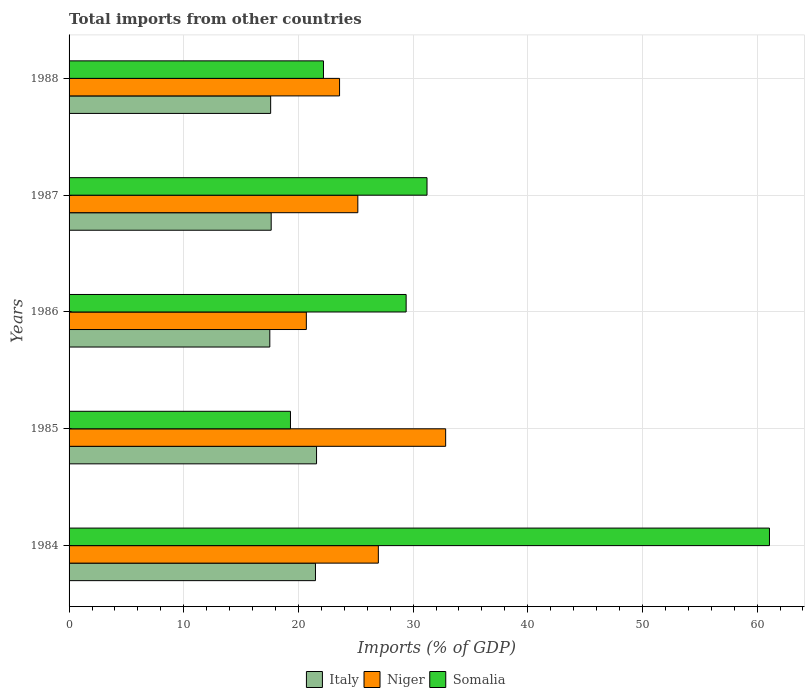How many different coloured bars are there?
Your response must be concise. 3. How many groups of bars are there?
Offer a terse response. 5. How many bars are there on the 2nd tick from the top?
Offer a very short reply. 3. What is the label of the 2nd group of bars from the top?
Provide a succinct answer. 1987. In how many cases, is the number of bars for a given year not equal to the number of legend labels?
Ensure brevity in your answer.  0. What is the total imports in Niger in 1984?
Provide a short and direct response. 26.97. Across all years, what is the maximum total imports in Italy?
Give a very brief answer. 21.58. Across all years, what is the minimum total imports in Niger?
Offer a terse response. 20.69. In which year was the total imports in Somalia maximum?
Your response must be concise. 1984. What is the total total imports in Somalia in the graph?
Provide a short and direct response. 163.18. What is the difference between the total imports in Somalia in 1985 and that in 1986?
Offer a terse response. -10.09. What is the difference between the total imports in Somalia in 1987 and the total imports in Italy in 1986?
Offer a terse response. 13.71. What is the average total imports in Niger per year?
Provide a succinct answer. 25.85. In the year 1984, what is the difference between the total imports in Italy and total imports in Niger?
Provide a short and direct response. -5.48. What is the ratio of the total imports in Somalia in 1984 to that in 1987?
Your response must be concise. 1.96. Is the total imports in Niger in 1985 less than that in 1986?
Provide a short and direct response. No. Is the difference between the total imports in Italy in 1987 and 1988 greater than the difference between the total imports in Niger in 1987 and 1988?
Your response must be concise. No. What is the difference between the highest and the second highest total imports in Somalia?
Provide a short and direct response. 29.86. What is the difference between the highest and the lowest total imports in Italy?
Give a very brief answer. 4.08. Is the sum of the total imports in Niger in 1984 and 1987 greater than the maximum total imports in Somalia across all years?
Make the answer very short. No. What does the 2nd bar from the bottom in 1986 represents?
Your response must be concise. Niger. Is it the case that in every year, the sum of the total imports in Somalia and total imports in Italy is greater than the total imports in Niger?
Your response must be concise. Yes. How many bars are there?
Give a very brief answer. 15. Are all the bars in the graph horizontal?
Give a very brief answer. Yes. How many years are there in the graph?
Provide a succinct answer. 5. Are the values on the major ticks of X-axis written in scientific E-notation?
Your answer should be compact. No. How are the legend labels stacked?
Your answer should be very brief. Horizontal. What is the title of the graph?
Give a very brief answer. Total imports from other countries. Does "Macao" appear as one of the legend labels in the graph?
Give a very brief answer. No. What is the label or title of the X-axis?
Offer a terse response. Imports (% of GDP). What is the label or title of the Y-axis?
Provide a succinct answer. Years. What is the Imports (% of GDP) of Italy in 1984?
Your answer should be very brief. 21.49. What is the Imports (% of GDP) in Niger in 1984?
Your answer should be compact. 26.97. What is the Imports (% of GDP) of Somalia in 1984?
Your answer should be very brief. 61.08. What is the Imports (% of GDP) of Italy in 1985?
Your answer should be compact. 21.58. What is the Imports (% of GDP) of Niger in 1985?
Offer a very short reply. 32.84. What is the Imports (% of GDP) in Somalia in 1985?
Your response must be concise. 19.31. What is the Imports (% of GDP) of Italy in 1986?
Offer a terse response. 17.51. What is the Imports (% of GDP) of Niger in 1986?
Provide a short and direct response. 20.69. What is the Imports (% of GDP) in Somalia in 1986?
Offer a very short reply. 29.39. What is the Imports (% of GDP) of Italy in 1987?
Your answer should be compact. 17.63. What is the Imports (% of GDP) in Niger in 1987?
Ensure brevity in your answer.  25.18. What is the Imports (% of GDP) of Somalia in 1987?
Offer a terse response. 31.21. What is the Imports (% of GDP) in Italy in 1988?
Your answer should be compact. 17.58. What is the Imports (% of GDP) of Niger in 1988?
Ensure brevity in your answer.  23.59. What is the Imports (% of GDP) of Somalia in 1988?
Offer a very short reply. 22.18. Across all years, what is the maximum Imports (% of GDP) in Italy?
Provide a short and direct response. 21.58. Across all years, what is the maximum Imports (% of GDP) of Niger?
Offer a terse response. 32.84. Across all years, what is the maximum Imports (% of GDP) of Somalia?
Keep it short and to the point. 61.08. Across all years, what is the minimum Imports (% of GDP) in Italy?
Your answer should be very brief. 17.51. Across all years, what is the minimum Imports (% of GDP) of Niger?
Keep it short and to the point. 20.69. Across all years, what is the minimum Imports (% of GDP) in Somalia?
Offer a very short reply. 19.31. What is the total Imports (% of GDP) in Italy in the graph?
Keep it short and to the point. 95.78. What is the total Imports (% of GDP) in Niger in the graph?
Keep it short and to the point. 129.27. What is the total Imports (% of GDP) of Somalia in the graph?
Provide a short and direct response. 163.18. What is the difference between the Imports (% of GDP) in Italy in 1984 and that in 1985?
Provide a succinct answer. -0.09. What is the difference between the Imports (% of GDP) of Niger in 1984 and that in 1985?
Your response must be concise. -5.87. What is the difference between the Imports (% of GDP) of Somalia in 1984 and that in 1985?
Your answer should be compact. 41.77. What is the difference between the Imports (% of GDP) in Italy in 1984 and that in 1986?
Make the answer very short. 3.98. What is the difference between the Imports (% of GDP) in Niger in 1984 and that in 1986?
Offer a terse response. 6.28. What is the difference between the Imports (% of GDP) of Somalia in 1984 and that in 1986?
Make the answer very short. 31.68. What is the difference between the Imports (% of GDP) of Italy in 1984 and that in 1987?
Make the answer very short. 3.86. What is the difference between the Imports (% of GDP) in Niger in 1984 and that in 1987?
Offer a very short reply. 1.79. What is the difference between the Imports (% of GDP) of Somalia in 1984 and that in 1987?
Offer a very short reply. 29.86. What is the difference between the Imports (% of GDP) of Italy in 1984 and that in 1988?
Give a very brief answer. 3.91. What is the difference between the Imports (% of GDP) in Niger in 1984 and that in 1988?
Provide a short and direct response. 3.38. What is the difference between the Imports (% of GDP) in Somalia in 1984 and that in 1988?
Your response must be concise. 38.89. What is the difference between the Imports (% of GDP) of Italy in 1985 and that in 1986?
Give a very brief answer. 4.08. What is the difference between the Imports (% of GDP) of Niger in 1985 and that in 1986?
Your answer should be very brief. 12.15. What is the difference between the Imports (% of GDP) in Somalia in 1985 and that in 1986?
Your response must be concise. -10.09. What is the difference between the Imports (% of GDP) of Italy in 1985 and that in 1987?
Offer a terse response. 3.96. What is the difference between the Imports (% of GDP) of Niger in 1985 and that in 1987?
Ensure brevity in your answer.  7.66. What is the difference between the Imports (% of GDP) in Somalia in 1985 and that in 1987?
Ensure brevity in your answer.  -11.91. What is the difference between the Imports (% of GDP) of Italy in 1985 and that in 1988?
Ensure brevity in your answer.  4. What is the difference between the Imports (% of GDP) of Niger in 1985 and that in 1988?
Make the answer very short. 9.25. What is the difference between the Imports (% of GDP) of Somalia in 1985 and that in 1988?
Offer a terse response. -2.88. What is the difference between the Imports (% of GDP) in Italy in 1986 and that in 1987?
Ensure brevity in your answer.  -0.12. What is the difference between the Imports (% of GDP) in Niger in 1986 and that in 1987?
Give a very brief answer. -4.49. What is the difference between the Imports (% of GDP) of Somalia in 1986 and that in 1987?
Offer a very short reply. -1.82. What is the difference between the Imports (% of GDP) in Italy in 1986 and that in 1988?
Provide a short and direct response. -0.07. What is the difference between the Imports (% of GDP) of Niger in 1986 and that in 1988?
Offer a very short reply. -2.9. What is the difference between the Imports (% of GDP) of Somalia in 1986 and that in 1988?
Provide a succinct answer. 7.21. What is the difference between the Imports (% of GDP) of Italy in 1987 and that in 1988?
Your answer should be very brief. 0.05. What is the difference between the Imports (% of GDP) of Niger in 1987 and that in 1988?
Your response must be concise. 1.59. What is the difference between the Imports (% of GDP) of Somalia in 1987 and that in 1988?
Offer a terse response. 9.03. What is the difference between the Imports (% of GDP) of Italy in 1984 and the Imports (% of GDP) of Niger in 1985?
Offer a terse response. -11.35. What is the difference between the Imports (% of GDP) in Italy in 1984 and the Imports (% of GDP) in Somalia in 1985?
Ensure brevity in your answer.  2.18. What is the difference between the Imports (% of GDP) of Niger in 1984 and the Imports (% of GDP) of Somalia in 1985?
Give a very brief answer. 7.66. What is the difference between the Imports (% of GDP) of Italy in 1984 and the Imports (% of GDP) of Niger in 1986?
Keep it short and to the point. 0.8. What is the difference between the Imports (% of GDP) of Italy in 1984 and the Imports (% of GDP) of Somalia in 1986?
Offer a very short reply. -7.91. What is the difference between the Imports (% of GDP) in Niger in 1984 and the Imports (% of GDP) in Somalia in 1986?
Your answer should be very brief. -2.42. What is the difference between the Imports (% of GDP) of Italy in 1984 and the Imports (% of GDP) of Niger in 1987?
Your answer should be very brief. -3.69. What is the difference between the Imports (% of GDP) of Italy in 1984 and the Imports (% of GDP) of Somalia in 1987?
Give a very brief answer. -9.73. What is the difference between the Imports (% of GDP) of Niger in 1984 and the Imports (% of GDP) of Somalia in 1987?
Make the answer very short. -4.24. What is the difference between the Imports (% of GDP) of Italy in 1984 and the Imports (% of GDP) of Niger in 1988?
Your answer should be very brief. -2.1. What is the difference between the Imports (% of GDP) in Italy in 1984 and the Imports (% of GDP) in Somalia in 1988?
Keep it short and to the point. -0.7. What is the difference between the Imports (% of GDP) in Niger in 1984 and the Imports (% of GDP) in Somalia in 1988?
Ensure brevity in your answer.  4.79. What is the difference between the Imports (% of GDP) in Italy in 1985 and the Imports (% of GDP) in Niger in 1986?
Ensure brevity in your answer.  0.89. What is the difference between the Imports (% of GDP) of Italy in 1985 and the Imports (% of GDP) of Somalia in 1986?
Provide a succinct answer. -7.81. What is the difference between the Imports (% of GDP) in Niger in 1985 and the Imports (% of GDP) in Somalia in 1986?
Provide a succinct answer. 3.45. What is the difference between the Imports (% of GDP) of Italy in 1985 and the Imports (% of GDP) of Niger in 1987?
Provide a short and direct response. -3.6. What is the difference between the Imports (% of GDP) of Italy in 1985 and the Imports (% of GDP) of Somalia in 1987?
Provide a short and direct response. -9.63. What is the difference between the Imports (% of GDP) of Niger in 1985 and the Imports (% of GDP) of Somalia in 1987?
Your answer should be very brief. 1.63. What is the difference between the Imports (% of GDP) of Italy in 1985 and the Imports (% of GDP) of Niger in 1988?
Your response must be concise. -2.01. What is the difference between the Imports (% of GDP) in Italy in 1985 and the Imports (% of GDP) in Somalia in 1988?
Keep it short and to the point. -0.6. What is the difference between the Imports (% of GDP) in Niger in 1985 and the Imports (% of GDP) in Somalia in 1988?
Keep it short and to the point. 10.66. What is the difference between the Imports (% of GDP) of Italy in 1986 and the Imports (% of GDP) of Niger in 1987?
Give a very brief answer. -7.68. What is the difference between the Imports (% of GDP) in Italy in 1986 and the Imports (% of GDP) in Somalia in 1987?
Offer a very short reply. -13.71. What is the difference between the Imports (% of GDP) of Niger in 1986 and the Imports (% of GDP) of Somalia in 1987?
Ensure brevity in your answer.  -10.52. What is the difference between the Imports (% of GDP) of Italy in 1986 and the Imports (% of GDP) of Niger in 1988?
Your response must be concise. -6.08. What is the difference between the Imports (% of GDP) in Italy in 1986 and the Imports (% of GDP) in Somalia in 1988?
Your response must be concise. -4.68. What is the difference between the Imports (% of GDP) of Niger in 1986 and the Imports (% of GDP) of Somalia in 1988?
Offer a very short reply. -1.49. What is the difference between the Imports (% of GDP) in Italy in 1987 and the Imports (% of GDP) in Niger in 1988?
Provide a short and direct response. -5.96. What is the difference between the Imports (% of GDP) of Italy in 1987 and the Imports (% of GDP) of Somalia in 1988?
Keep it short and to the point. -4.56. What is the difference between the Imports (% of GDP) in Niger in 1987 and the Imports (% of GDP) in Somalia in 1988?
Your answer should be very brief. 3. What is the average Imports (% of GDP) in Italy per year?
Give a very brief answer. 19.16. What is the average Imports (% of GDP) in Niger per year?
Ensure brevity in your answer.  25.85. What is the average Imports (% of GDP) of Somalia per year?
Give a very brief answer. 32.64. In the year 1984, what is the difference between the Imports (% of GDP) of Italy and Imports (% of GDP) of Niger?
Provide a short and direct response. -5.48. In the year 1984, what is the difference between the Imports (% of GDP) of Italy and Imports (% of GDP) of Somalia?
Your answer should be compact. -39.59. In the year 1984, what is the difference between the Imports (% of GDP) in Niger and Imports (% of GDP) in Somalia?
Ensure brevity in your answer.  -34.11. In the year 1985, what is the difference between the Imports (% of GDP) in Italy and Imports (% of GDP) in Niger?
Your response must be concise. -11.26. In the year 1985, what is the difference between the Imports (% of GDP) of Italy and Imports (% of GDP) of Somalia?
Your response must be concise. 2.27. In the year 1985, what is the difference between the Imports (% of GDP) in Niger and Imports (% of GDP) in Somalia?
Your answer should be compact. 13.53. In the year 1986, what is the difference between the Imports (% of GDP) in Italy and Imports (% of GDP) in Niger?
Ensure brevity in your answer.  -3.19. In the year 1986, what is the difference between the Imports (% of GDP) in Italy and Imports (% of GDP) in Somalia?
Your response must be concise. -11.89. In the year 1986, what is the difference between the Imports (% of GDP) in Niger and Imports (% of GDP) in Somalia?
Offer a terse response. -8.7. In the year 1987, what is the difference between the Imports (% of GDP) of Italy and Imports (% of GDP) of Niger?
Make the answer very short. -7.56. In the year 1987, what is the difference between the Imports (% of GDP) in Italy and Imports (% of GDP) in Somalia?
Provide a succinct answer. -13.59. In the year 1987, what is the difference between the Imports (% of GDP) of Niger and Imports (% of GDP) of Somalia?
Your response must be concise. -6.03. In the year 1988, what is the difference between the Imports (% of GDP) of Italy and Imports (% of GDP) of Niger?
Your answer should be compact. -6.01. In the year 1988, what is the difference between the Imports (% of GDP) of Italy and Imports (% of GDP) of Somalia?
Provide a succinct answer. -4.61. In the year 1988, what is the difference between the Imports (% of GDP) in Niger and Imports (% of GDP) in Somalia?
Your answer should be very brief. 1.4. What is the ratio of the Imports (% of GDP) in Niger in 1984 to that in 1985?
Keep it short and to the point. 0.82. What is the ratio of the Imports (% of GDP) of Somalia in 1984 to that in 1985?
Your response must be concise. 3.16. What is the ratio of the Imports (% of GDP) in Italy in 1984 to that in 1986?
Provide a succinct answer. 1.23. What is the ratio of the Imports (% of GDP) in Niger in 1984 to that in 1986?
Provide a succinct answer. 1.3. What is the ratio of the Imports (% of GDP) of Somalia in 1984 to that in 1986?
Your answer should be compact. 2.08. What is the ratio of the Imports (% of GDP) in Italy in 1984 to that in 1987?
Provide a short and direct response. 1.22. What is the ratio of the Imports (% of GDP) in Niger in 1984 to that in 1987?
Make the answer very short. 1.07. What is the ratio of the Imports (% of GDP) of Somalia in 1984 to that in 1987?
Provide a short and direct response. 1.96. What is the ratio of the Imports (% of GDP) in Italy in 1984 to that in 1988?
Give a very brief answer. 1.22. What is the ratio of the Imports (% of GDP) in Niger in 1984 to that in 1988?
Ensure brevity in your answer.  1.14. What is the ratio of the Imports (% of GDP) of Somalia in 1984 to that in 1988?
Your response must be concise. 2.75. What is the ratio of the Imports (% of GDP) in Italy in 1985 to that in 1986?
Your answer should be compact. 1.23. What is the ratio of the Imports (% of GDP) in Niger in 1985 to that in 1986?
Ensure brevity in your answer.  1.59. What is the ratio of the Imports (% of GDP) in Somalia in 1985 to that in 1986?
Offer a very short reply. 0.66. What is the ratio of the Imports (% of GDP) of Italy in 1985 to that in 1987?
Offer a terse response. 1.22. What is the ratio of the Imports (% of GDP) in Niger in 1985 to that in 1987?
Make the answer very short. 1.3. What is the ratio of the Imports (% of GDP) of Somalia in 1985 to that in 1987?
Your response must be concise. 0.62. What is the ratio of the Imports (% of GDP) in Italy in 1985 to that in 1988?
Give a very brief answer. 1.23. What is the ratio of the Imports (% of GDP) of Niger in 1985 to that in 1988?
Ensure brevity in your answer.  1.39. What is the ratio of the Imports (% of GDP) of Somalia in 1985 to that in 1988?
Provide a short and direct response. 0.87. What is the ratio of the Imports (% of GDP) in Italy in 1986 to that in 1987?
Your answer should be very brief. 0.99. What is the ratio of the Imports (% of GDP) in Niger in 1986 to that in 1987?
Provide a short and direct response. 0.82. What is the ratio of the Imports (% of GDP) in Somalia in 1986 to that in 1987?
Offer a very short reply. 0.94. What is the ratio of the Imports (% of GDP) of Italy in 1986 to that in 1988?
Your answer should be compact. 1. What is the ratio of the Imports (% of GDP) in Niger in 1986 to that in 1988?
Make the answer very short. 0.88. What is the ratio of the Imports (% of GDP) of Somalia in 1986 to that in 1988?
Your answer should be very brief. 1.32. What is the ratio of the Imports (% of GDP) of Italy in 1987 to that in 1988?
Provide a short and direct response. 1. What is the ratio of the Imports (% of GDP) of Niger in 1987 to that in 1988?
Provide a short and direct response. 1.07. What is the ratio of the Imports (% of GDP) in Somalia in 1987 to that in 1988?
Offer a terse response. 1.41. What is the difference between the highest and the second highest Imports (% of GDP) in Italy?
Offer a terse response. 0.09. What is the difference between the highest and the second highest Imports (% of GDP) in Niger?
Give a very brief answer. 5.87. What is the difference between the highest and the second highest Imports (% of GDP) of Somalia?
Your answer should be very brief. 29.86. What is the difference between the highest and the lowest Imports (% of GDP) in Italy?
Give a very brief answer. 4.08. What is the difference between the highest and the lowest Imports (% of GDP) in Niger?
Offer a terse response. 12.15. What is the difference between the highest and the lowest Imports (% of GDP) in Somalia?
Make the answer very short. 41.77. 